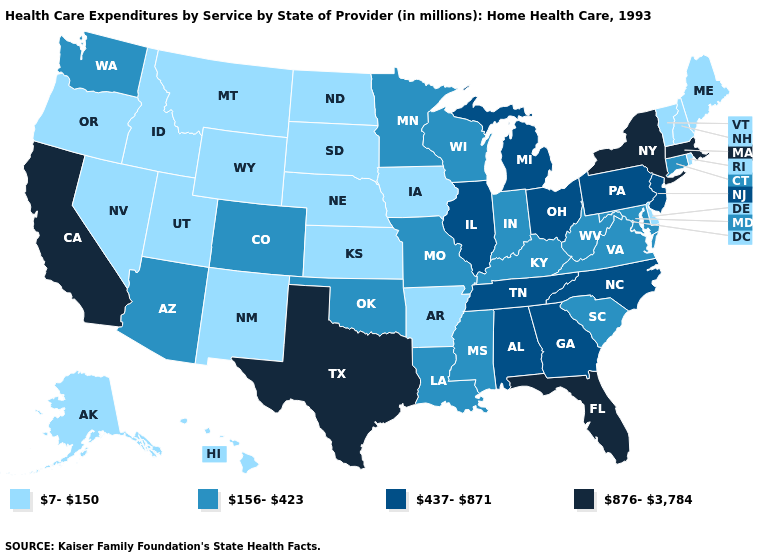What is the lowest value in states that border West Virginia?
Quick response, please. 156-423. Does Pennsylvania have the lowest value in the Northeast?
Write a very short answer. No. Among the states that border Kentucky , does Virginia have the highest value?
Quick response, please. No. How many symbols are there in the legend?
Short answer required. 4. Does South Carolina have the same value as Connecticut?
Short answer required. Yes. What is the lowest value in states that border Idaho?
Concise answer only. 7-150. What is the highest value in the USA?
Quick response, please. 876-3,784. What is the value of Washington?
Write a very short answer. 156-423. Among the states that border Missouri , which have the highest value?
Keep it brief. Illinois, Tennessee. Which states have the lowest value in the USA?
Quick response, please. Alaska, Arkansas, Delaware, Hawaii, Idaho, Iowa, Kansas, Maine, Montana, Nebraska, Nevada, New Hampshire, New Mexico, North Dakota, Oregon, Rhode Island, South Dakota, Utah, Vermont, Wyoming. What is the value of New York?
Quick response, please. 876-3,784. What is the value of Ohio?
Answer briefly. 437-871. Among the states that border California , which have the lowest value?
Keep it brief. Nevada, Oregon. What is the value of Oregon?
Quick response, please. 7-150. What is the value of Wisconsin?
Write a very short answer. 156-423. 